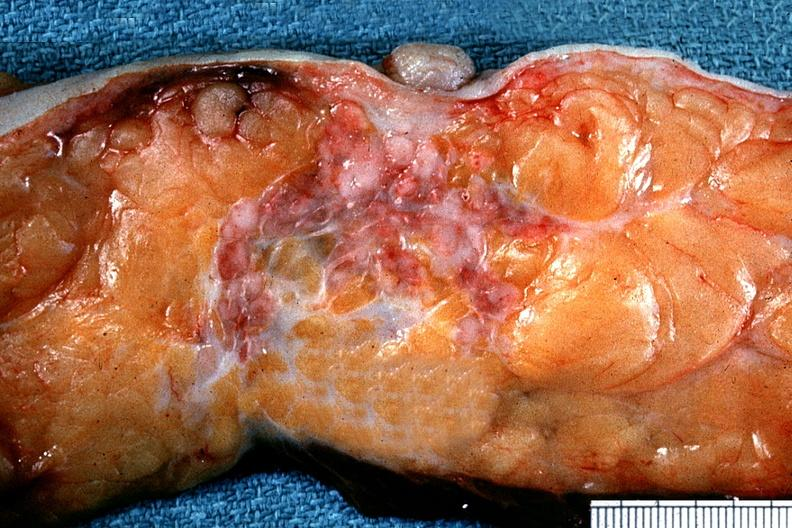what is present?
Answer the question using a single word or phrase. Adenocarcinoma 